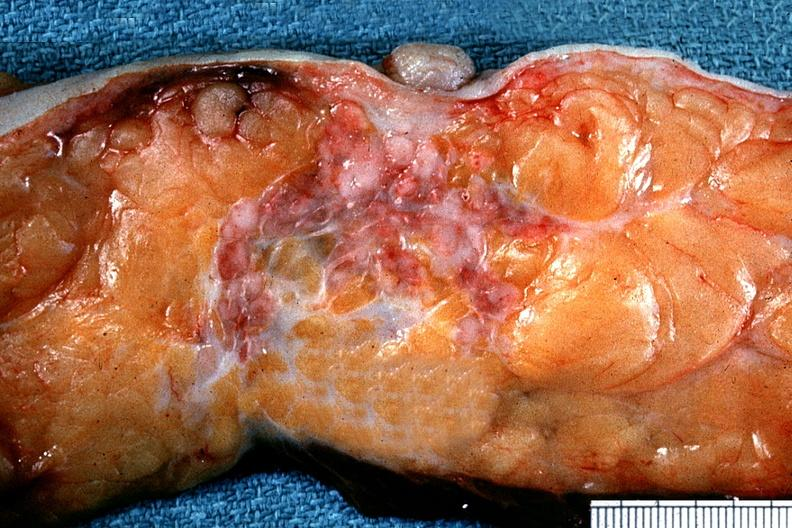what is present?
Answer the question using a single word or phrase. Adenocarcinoma 